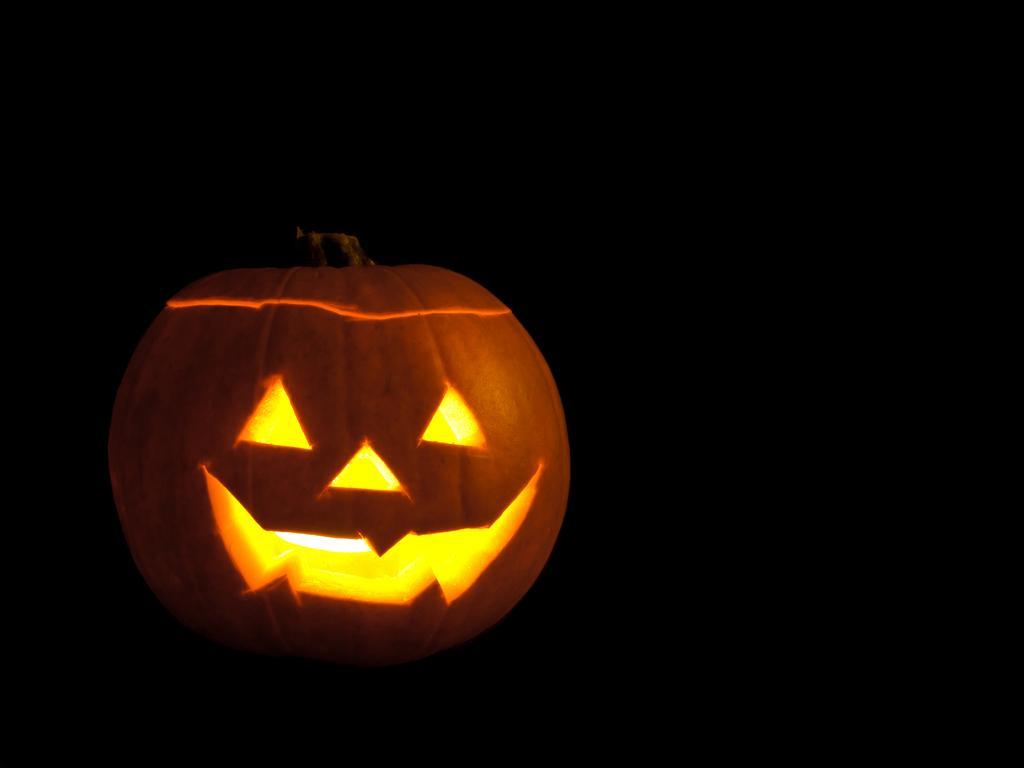How would you summarize this image in a sentence or two? In this picture, we can see a pumpkin with some design on it, and we can see the dark background. 